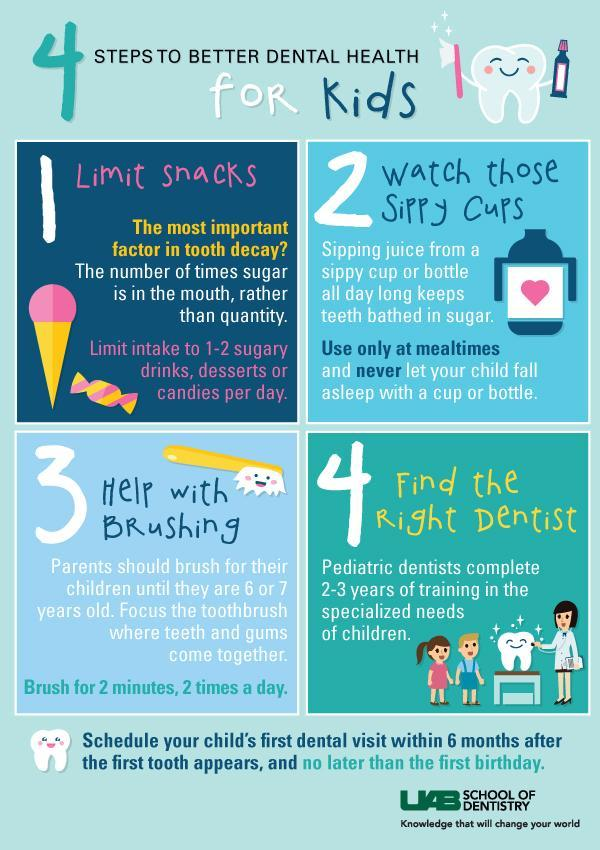when should a kid have their first dental visit according to the recommendations listed in the infographic?
Answer the question with a short phrase. after the first tooth appears How many total minutes of brushing is recommended for kids each day? 4 